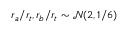Convert formula to latex. <formula><loc_0><loc_0><loc_500><loc_500>r _ { a } / r _ { t } , r _ { b } / r _ { t } \sim \mathcal { N } ( 2 , 1 / 6 )</formula> 